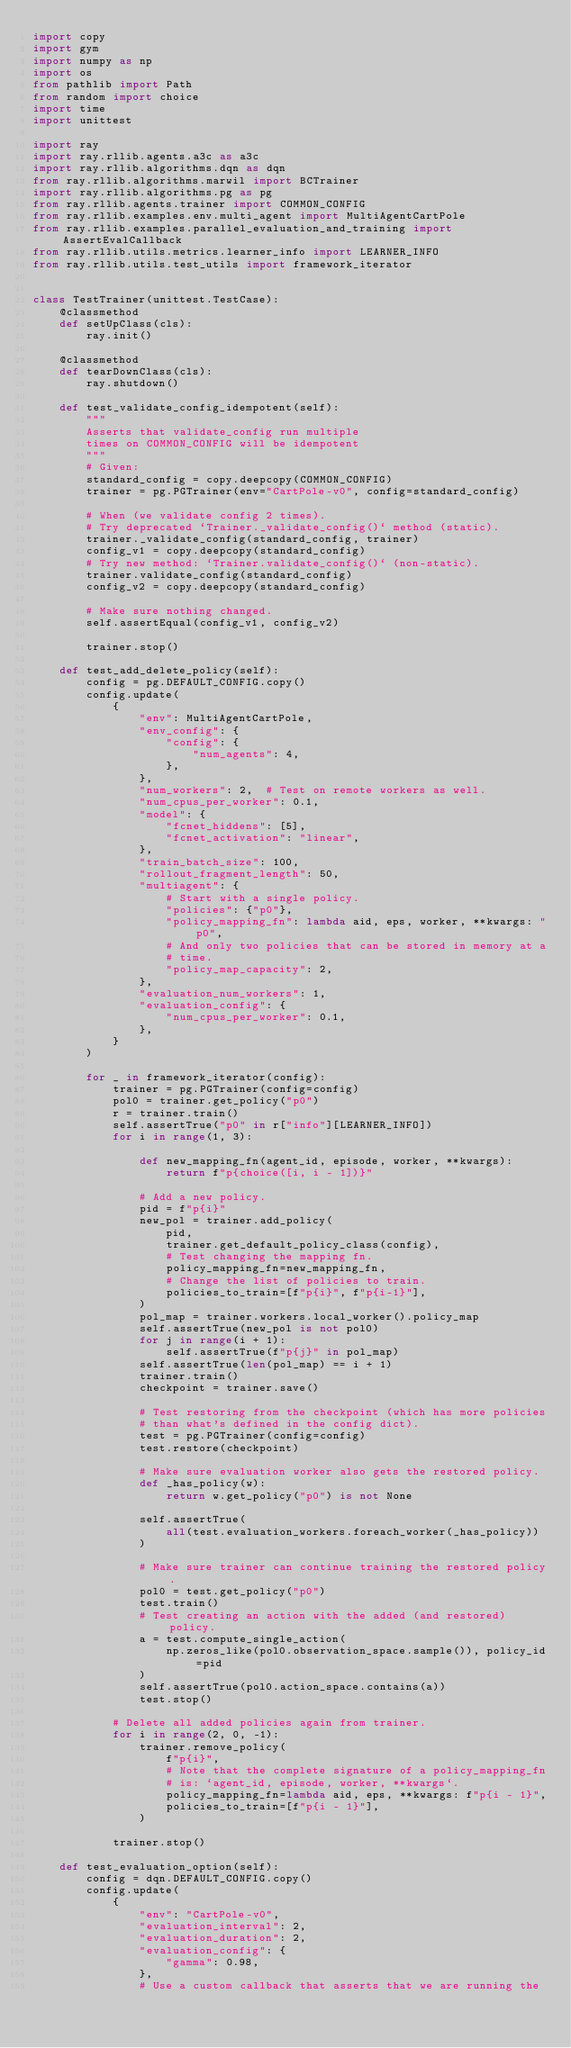Convert code to text. <code><loc_0><loc_0><loc_500><loc_500><_Python_>import copy
import gym
import numpy as np
import os
from pathlib import Path
from random import choice
import time
import unittest

import ray
import ray.rllib.agents.a3c as a3c
import ray.rllib.algorithms.dqn as dqn
from ray.rllib.algorithms.marwil import BCTrainer
import ray.rllib.algorithms.pg as pg
from ray.rllib.agents.trainer import COMMON_CONFIG
from ray.rllib.examples.env.multi_agent import MultiAgentCartPole
from ray.rllib.examples.parallel_evaluation_and_training import AssertEvalCallback
from ray.rllib.utils.metrics.learner_info import LEARNER_INFO
from ray.rllib.utils.test_utils import framework_iterator


class TestTrainer(unittest.TestCase):
    @classmethod
    def setUpClass(cls):
        ray.init()

    @classmethod
    def tearDownClass(cls):
        ray.shutdown()

    def test_validate_config_idempotent(self):
        """
        Asserts that validate_config run multiple
        times on COMMON_CONFIG will be idempotent
        """
        # Given:
        standard_config = copy.deepcopy(COMMON_CONFIG)
        trainer = pg.PGTrainer(env="CartPole-v0", config=standard_config)

        # When (we validate config 2 times).
        # Try deprecated `Trainer._validate_config()` method (static).
        trainer._validate_config(standard_config, trainer)
        config_v1 = copy.deepcopy(standard_config)
        # Try new method: `Trainer.validate_config()` (non-static).
        trainer.validate_config(standard_config)
        config_v2 = copy.deepcopy(standard_config)

        # Make sure nothing changed.
        self.assertEqual(config_v1, config_v2)

        trainer.stop()

    def test_add_delete_policy(self):
        config = pg.DEFAULT_CONFIG.copy()
        config.update(
            {
                "env": MultiAgentCartPole,
                "env_config": {
                    "config": {
                        "num_agents": 4,
                    },
                },
                "num_workers": 2,  # Test on remote workers as well.
                "num_cpus_per_worker": 0.1,
                "model": {
                    "fcnet_hiddens": [5],
                    "fcnet_activation": "linear",
                },
                "train_batch_size": 100,
                "rollout_fragment_length": 50,
                "multiagent": {
                    # Start with a single policy.
                    "policies": {"p0"},
                    "policy_mapping_fn": lambda aid, eps, worker, **kwargs: "p0",
                    # And only two policies that can be stored in memory at a
                    # time.
                    "policy_map_capacity": 2,
                },
                "evaluation_num_workers": 1,
                "evaluation_config": {
                    "num_cpus_per_worker": 0.1,
                },
            }
        )

        for _ in framework_iterator(config):
            trainer = pg.PGTrainer(config=config)
            pol0 = trainer.get_policy("p0")
            r = trainer.train()
            self.assertTrue("p0" in r["info"][LEARNER_INFO])
            for i in range(1, 3):

                def new_mapping_fn(agent_id, episode, worker, **kwargs):
                    return f"p{choice([i, i - 1])}"

                # Add a new policy.
                pid = f"p{i}"
                new_pol = trainer.add_policy(
                    pid,
                    trainer.get_default_policy_class(config),
                    # Test changing the mapping fn.
                    policy_mapping_fn=new_mapping_fn,
                    # Change the list of policies to train.
                    policies_to_train=[f"p{i}", f"p{i-1}"],
                )
                pol_map = trainer.workers.local_worker().policy_map
                self.assertTrue(new_pol is not pol0)
                for j in range(i + 1):
                    self.assertTrue(f"p{j}" in pol_map)
                self.assertTrue(len(pol_map) == i + 1)
                trainer.train()
                checkpoint = trainer.save()

                # Test restoring from the checkpoint (which has more policies
                # than what's defined in the config dict).
                test = pg.PGTrainer(config=config)
                test.restore(checkpoint)

                # Make sure evaluation worker also gets the restored policy.
                def _has_policy(w):
                    return w.get_policy("p0") is not None

                self.assertTrue(
                    all(test.evaluation_workers.foreach_worker(_has_policy))
                )

                # Make sure trainer can continue training the restored policy.
                pol0 = test.get_policy("p0")
                test.train()
                # Test creating an action with the added (and restored) policy.
                a = test.compute_single_action(
                    np.zeros_like(pol0.observation_space.sample()), policy_id=pid
                )
                self.assertTrue(pol0.action_space.contains(a))
                test.stop()

            # Delete all added policies again from trainer.
            for i in range(2, 0, -1):
                trainer.remove_policy(
                    f"p{i}",
                    # Note that the complete signature of a policy_mapping_fn
                    # is: `agent_id, episode, worker, **kwargs`.
                    policy_mapping_fn=lambda aid, eps, **kwargs: f"p{i - 1}",
                    policies_to_train=[f"p{i - 1}"],
                )

            trainer.stop()

    def test_evaluation_option(self):
        config = dqn.DEFAULT_CONFIG.copy()
        config.update(
            {
                "env": "CartPole-v0",
                "evaluation_interval": 2,
                "evaluation_duration": 2,
                "evaluation_config": {
                    "gamma": 0.98,
                },
                # Use a custom callback that asserts that we are running the</code> 